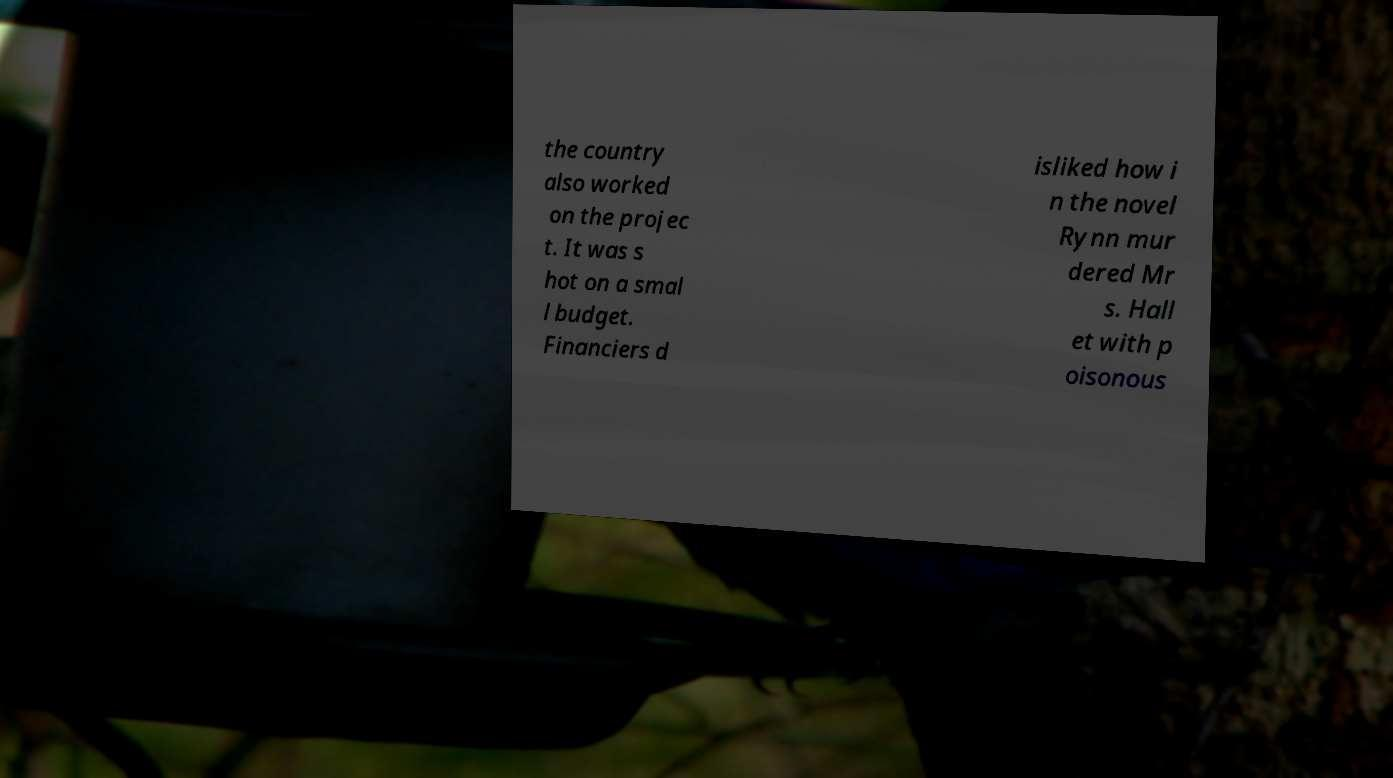Please identify and transcribe the text found in this image. the country also worked on the projec t. It was s hot on a smal l budget. Financiers d isliked how i n the novel Rynn mur dered Mr s. Hall et with p oisonous 